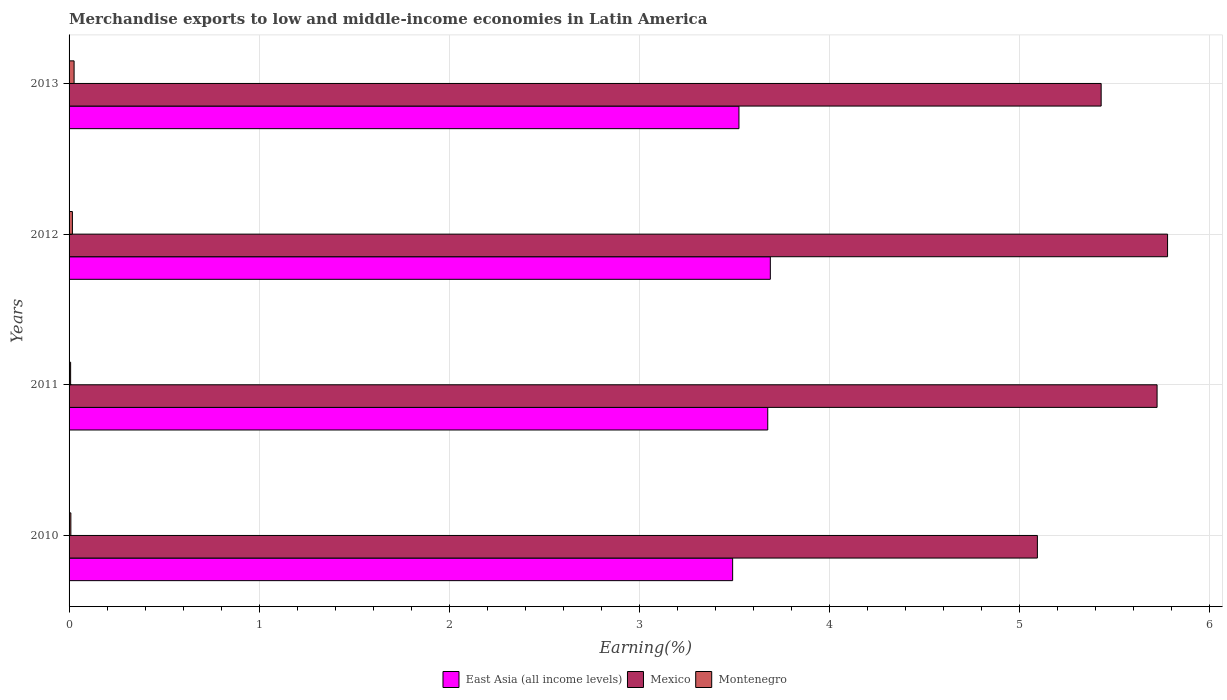How many different coloured bars are there?
Offer a terse response. 3. How many bars are there on the 4th tick from the top?
Offer a terse response. 3. How many bars are there on the 1st tick from the bottom?
Your answer should be very brief. 3. What is the label of the 1st group of bars from the top?
Keep it short and to the point. 2013. What is the percentage of amount earned from merchandise exports in East Asia (all income levels) in 2012?
Your answer should be compact. 3.69. Across all years, what is the maximum percentage of amount earned from merchandise exports in East Asia (all income levels)?
Provide a short and direct response. 3.69. Across all years, what is the minimum percentage of amount earned from merchandise exports in Montenegro?
Make the answer very short. 0.01. What is the total percentage of amount earned from merchandise exports in Montenegro in the graph?
Offer a terse response. 0.06. What is the difference between the percentage of amount earned from merchandise exports in Mexico in 2012 and that in 2013?
Keep it short and to the point. 0.35. What is the difference between the percentage of amount earned from merchandise exports in Mexico in 2013 and the percentage of amount earned from merchandise exports in East Asia (all income levels) in 2012?
Offer a very short reply. 1.74. What is the average percentage of amount earned from merchandise exports in Mexico per year?
Offer a terse response. 5.51. In the year 2013, what is the difference between the percentage of amount earned from merchandise exports in Mexico and percentage of amount earned from merchandise exports in Montenegro?
Your answer should be compact. 5.4. In how many years, is the percentage of amount earned from merchandise exports in East Asia (all income levels) greater than 0.6000000000000001 %?
Ensure brevity in your answer.  4. What is the ratio of the percentage of amount earned from merchandise exports in East Asia (all income levels) in 2011 to that in 2012?
Make the answer very short. 1. Is the percentage of amount earned from merchandise exports in East Asia (all income levels) in 2010 less than that in 2012?
Ensure brevity in your answer.  Yes. What is the difference between the highest and the second highest percentage of amount earned from merchandise exports in East Asia (all income levels)?
Provide a succinct answer. 0.01. What is the difference between the highest and the lowest percentage of amount earned from merchandise exports in Mexico?
Your answer should be compact. 0.68. Is the sum of the percentage of amount earned from merchandise exports in Montenegro in 2010 and 2012 greater than the maximum percentage of amount earned from merchandise exports in Mexico across all years?
Offer a terse response. No. What does the 2nd bar from the top in 2013 represents?
Keep it short and to the point. Mexico. What does the 1st bar from the bottom in 2010 represents?
Provide a succinct answer. East Asia (all income levels). What is the difference between two consecutive major ticks on the X-axis?
Offer a very short reply. 1. Are the values on the major ticks of X-axis written in scientific E-notation?
Your response must be concise. No. Does the graph contain grids?
Your answer should be compact. Yes. Where does the legend appear in the graph?
Offer a terse response. Bottom center. How are the legend labels stacked?
Keep it short and to the point. Horizontal. What is the title of the graph?
Your answer should be compact. Merchandise exports to low and middle-income economies in Latin America. What is the label or title of the X-axis?
Offer a terse response. Earning(%). What is the Earning(%) of East Asia (all income levels) in 2010?
Provide a short and direct response. 3.49. What is the Earning(%) in Mexico in 2010?
Keep it short and to the point. 5.09. What is the Earning(%) in Montenegro in 2010?
Ensure brevity in your answer.  0.01. What is the Earning(%) of East Asia (all income levels) in 2011?
Offer a terse response. 3.68. What is the Earning(%) in Mexico in 2011?
Offer a very short reply. 5.72. What is the Earning(%) of Montenegro in 2011?
Your response must be concise. 0.01. What is the Earning(%) in East Asia (all income levels) in 2012?
Keep it short and to the point. 3.69. What is the Earning(%) of Mexico in 2012?
Give a very brief answer. 5.78. What is the Earning(%) in Montenegro in 2012?
Provide a short and direct response. 0.02. What is the Earning(%) in East Asia (all income levels) in 2013?
Offer a terse response. 3.52. What is the Earning(%) in Mexico in 2013?
Offer a terse response. 5.43. What is the Earning(%) in Montenegro in 2013?
Offer a very short reply. 0.03. Across all years, what is the maximum Earning(%) in East Asia (all income levels)?
Provide a short and direct response. 3.69. Across all years, what is the maximum Earning(%) of Mexico?
Your answer should be very brief. 5.78. Across all years, what is the maximum Earning(%) of Montenegro?
Provide a succinct answer. 0.03. Across all years, what is the minimum Earning(%) of East Asia (all income levels)?
Offer a very short reply. 3.49. Across all years, what is the minimum Earning(%) in Mexico?
Make the answer very short. 5.09. Across all years, what is the minimum Earning(%) in Montenegro?
Give a very brief answer. 0.01. What is the total Earning(%) in East Asia (all income levels) in the graph?
Your answer should be compact. 14.38. What is the total Earning(%) of Mexico in the graph?
Your response must be concise. 22.03. What is the total Earning(%) in Montenegro in the graph?
Provide a short and direct response. 0.06. What is the difference between the Earning(%) of East Asia (all income levels) in 2010 and that in 2011?
Give a very brief answer. -0.18. What is the difference between the Earning(%) of Mexico in 2010 and that in 2011?
Provide a succinct answer. -0.63. What is the difference between the Earning(%) in Montenegro in 2010 and that in 2011?
Your answer should be compact. 0. What is the difference between the Earning(%) of East Asia (all income levels) in 2010 and that in 2012?
Offer a terse response. -0.2. What is the difference between the Earning(%) of Mexico in 2010 and that in 2012?
Your response must be concise. -0.68. What is the difference between the Earning(%) in Montenegro in 2010 and that in 2012?
Make the answer very short. -0.01. What is the difference between the Earning(%) in East Asia (all income levels) in 2010 and that in 2013?
Offer a terse response. -0.03. What is the difference between the Earning(%) in Mexico in 2010 and that in 2013?
Your answer should be very brief. -0.34. What is the difference between the Earning(%) in Montenegro in 2010 and that in 2013?
Make the answer very short. -0.02. What is the difference between the Earning(%) of East Asia (all income levels) in 2011 and that in 2012?
Offer a terse response. -0.01. What is the difference between the Earning(%) of Mexico in 2011 and that in 2012?
Your response must be concise. -0.06. What is the difference between the Earning(%) of Montenegro in 2011 and that in 2012?
Offer a very short reply. -0.01. What is the difference between the Earning(%) in East Asia (all income levels) in 2011 and that in 2013?
Provide a short and direct response. 0.15. What is the difference between the Earning(%) in Mexico in 2011 and that in 2013?
Provide a short and direct response. 0.29. What is the difference between the Earning(%) in Montenegro in 2011 and that in 2013?
Offer a terse response. -0.02. What is the difference between the Earning(%) in East Asia (all income levels) in 2012 and that in 2013?
Provide a short and direct response. 0.17. What is the difference between the Earning(%) in Mexico in 2012 and that in 2013?
Give a very brief answer. 0.35. What is the difference between the Earning(%) in Montenegro in 2012 and that in 2013?
Provide a succinct answer. -0.01. What is the difference between the Earning(%) of East Asia (all income levels) in 2010 and the Earning(%) of Mexico in 2011?
Keep it short and to the point. -2.23. What is the difference between the Earning(%) of East Asia (all income levels) in 2010 and the Earning(%) of Montenegro in 2011?
Give a very brief answer. 3.48. What is the difference between the Earning(%) of Mexico in 2010 and the Earning(%) of Montenegro in 2011?
Keep it short and to the point. 5.09. What is the difference between the Earning(%) of East Asia (all income levels) in 2010 and the Earning(%) of Mexico in 2012?
Provide a short and direct response. -2.29. What is the difference between the Earning(%) of East Asia (all income levels) in 2010 and the Earning(%) of Montenegro in 2012?
Offer a terse response. 3.47. What is the difference between the Earning(%) in Mexico in 2010 and the Earning(%) in Montenegro in 2012?
Keep it short and to the point. 5.08. What is the difference between the Earning(%) in East Asia (all income levels) in 2010 and the Earning(%) in Mexico in 2013?
Offer a terse response. -1.94. What is the difference between the Earning(%) of East Asia (all income levels) in 2010 and the Earning(%) of Montenegro in 2013?
Provide a short and direct response. 3.46. What is the difference between the Earning(%) in Mexico in 2010 and the Earning(%) in Montenegro in 2013?
Provide a succinct answer. 5.07. What is the difference between the Earning(%) of East Asia (all income levels) in 2011 and the Earning(%) of Mexico in 2012?
Your answer should be very brief. -2.1. What is the difference between the Earning(%) in East Asia (all income levels) in 2011 and the Earning(%) in Montenegro in 2012?
Make the answer very short. 3.66. What is the difference between the Earning(%) in Mexico in 2011 and the Earning(%) in Montenegro in 2012?
Ensure brevity in your answer.  5.71. What is the difference between the Earning(%) of East Asia (all income levels) in 2011 and the Earning(%) of Mexico in 2013?
Keep it short and to the point. -1.75. What is the difference between the Earning(%) in East Asia (all income levels) in 2011 and the Earning(%) in Montenegro in 2013?
Provide a succinct answer. 3.65. What is the difference between the Earning(%) in Mexico in 2011 and the Earning(%) in Montenegro in 2013?
Provide a succinct answer. 5.7. What is the difference between the Earning(%) in East Asia (all income levels) in 2012 and the Earning(%) in Mexico in 2013?
Ensure brevity in your answer.  -1.74. What is the difference between the Earning(%) of East Asia (all income levels) in 2012 and the Earning(%) of Montenegro in 2013?
Offer a terse response. 3.66. What is the difference between the Earning(%) in Mexico in 2012 and the Earning(%) in Montenegro in 2013?
Your response must be concise. 5.75. What is the average Earning(%) of East Asia (all income levels) per year?
Provide a succinct answer. 3.6. What is the average Earning(%) of Mexico per year?
Ensure brevity in your answer.  5.51. What is the average Earning(%) in Montenegro per year?
Keep it short and to the point. 0.02. In the year 2010, what is the difference between the Earning(%) in East Asia (all income levels) and Earning(%) in Mexico?
Make the answer very short. -1.6. In the year 2010, what is the difference between the Earning(%) of East Asia (all income levels) and Earning(%) of Montenegro?
Ensure brevity in your answer.  3.48. In the year 2010, what is the difference between the Earning(%) in Mexico and Earning(%) in Montenegro?
Offer a terse response. 5.08. In the year 2011, what is the difference between the Earning(%) of East Asia (all income levels) and Earning(%) of Mexico?
Keep it short and to the point. -2.05. In the year 2011, what is the difference between the Earning(%) of East Asia (all income levels) and Earning(%) of Montenegro?
Provide a short and direct response. 3.67. In the year 2011, what is the difference between the Earning(%) in Mexico and Earning(%) in Montenegro?
Offer a terse response. 5.72. In the year 2012, what is the difference between the Earning(%) of East Asia (all income levels) and Earning(%) of Mexico?
Offer a terse response. -2.09. In the year 2012, what is the difference between the Earning(%) of East Asia (all income levels) and Earning(%) of Montenegro?
Offer a terse response. 3.67. In the year 2012, what is the difference between the Earning(%) in Mexico and Earning(%) in Montenegro?
Provide a short and direct response. 5.76. In the year 2013, what is the difference between the Earning(%) of East Asia (all income levels) and Earning(%) of Mexico?
Ensure brevity in your answer.  -1.91. In the year 2013, what is the difference between the Earning(%) of East Asia (all income levels) and Earning(%) of Montenegro?
Give a very brief answer. 3.5. In the year 2013, what is the difference between the Earning(%) of Mexico and Earning(%) of Montenegro?
Keep it short and to the point. 5.4. What is the ratio of the Earning(%) of East Asia (all income levels) in 2010 to that in 2011?
Provide a short and direct response. 0.95. What is the ratio of the Earning(%) of Mexico in 2010 to that in 2011?
Offer a terse response. 0.89. What is the ratio of the Earning(%) of Montenegro in 2010 to that in 2011?
Provide a succinct answer. 1.15. What is the ratio of the Earning(%) of East Asia (all income levels) in 2010 to that in 2012?
Offer a very short reply. 0.95. What is the ratio of the Earning(%) of Mexico in 2010 to that in 2012?
Ensure brevity in your answer.  0.88. What is the ratio of the Earning(%) of Montenegro in 2010 to that in 2012?
Your answer should be compact. 0.54. What is the ratio of the Earning(%) of East Asia (all income levels) in 2010 to that in 2013?
Offer a terse response. 0.99. What is the ratio of the Earning(%) of Mexico in 2010 to that in 2013?
Your response must be concise. 0.94. What is the ratio of the Earning(%) in Montenegro in 2010 to that in 2013?
Provide a succinct answer. 0.36. What is the ratio of the Earning(%) of East Asia (all income levels) in 2011 to that in 2012?
Provide a short and direct response. 1. What is the ratio of the Earning(%) of Montenegro in 2011 to that in 2012?
Your answer should be compact. 0.47. What is the ratio of the Earning(%) of East Asia (all income levels) in 2011 to that in 2013?
Your answer should be compact. 1.04. What is the ratio of the Earning(%) of Mexico in 2011 to that in 2013?
Provide a short and direct response. 1.05. What is the ratio of the Earning(%) in Montenegro in 2011 to that in 2013?
Offer a very short reply. 0.31. What is the ratio of the Earning(%) of East Asia (all income levels) in 2012 to that in 2013?
Make the answer very short. 1.05. What is the ratio of the Earning(%) of Mexico in 2012 to that in 2013?
Provide a short and direct response. 1.06. What is the ratio of the Earning(%) in Montenegro in 2012 to that in 2013?
Your response must be concise. 0.66. What is the difference between the highest and the second highest Earning(%) of East Asia (all income levels)?
Ensure brevity in your answer.  0.01. What is the difference between the highest and the second highest Earning(%) of Mexico?
Your answer should be very brief. 0.06. What is the difference between the highest and the second highest Earning(%) of Montenegro?
Make the answer very short. 0.01. What is the difference between the highest and the lowest Earning(%) in East Asia (all income levels)?
Offer a terse response. 0.2. What is the difference between the highest and the lowest Earning(%) of Mexico?
Ensure brevity in your answer.  0.68. What is the difference between the highest and the lowest Earning(%) in Montenegro?
Your answer should be compact. 0.02. 